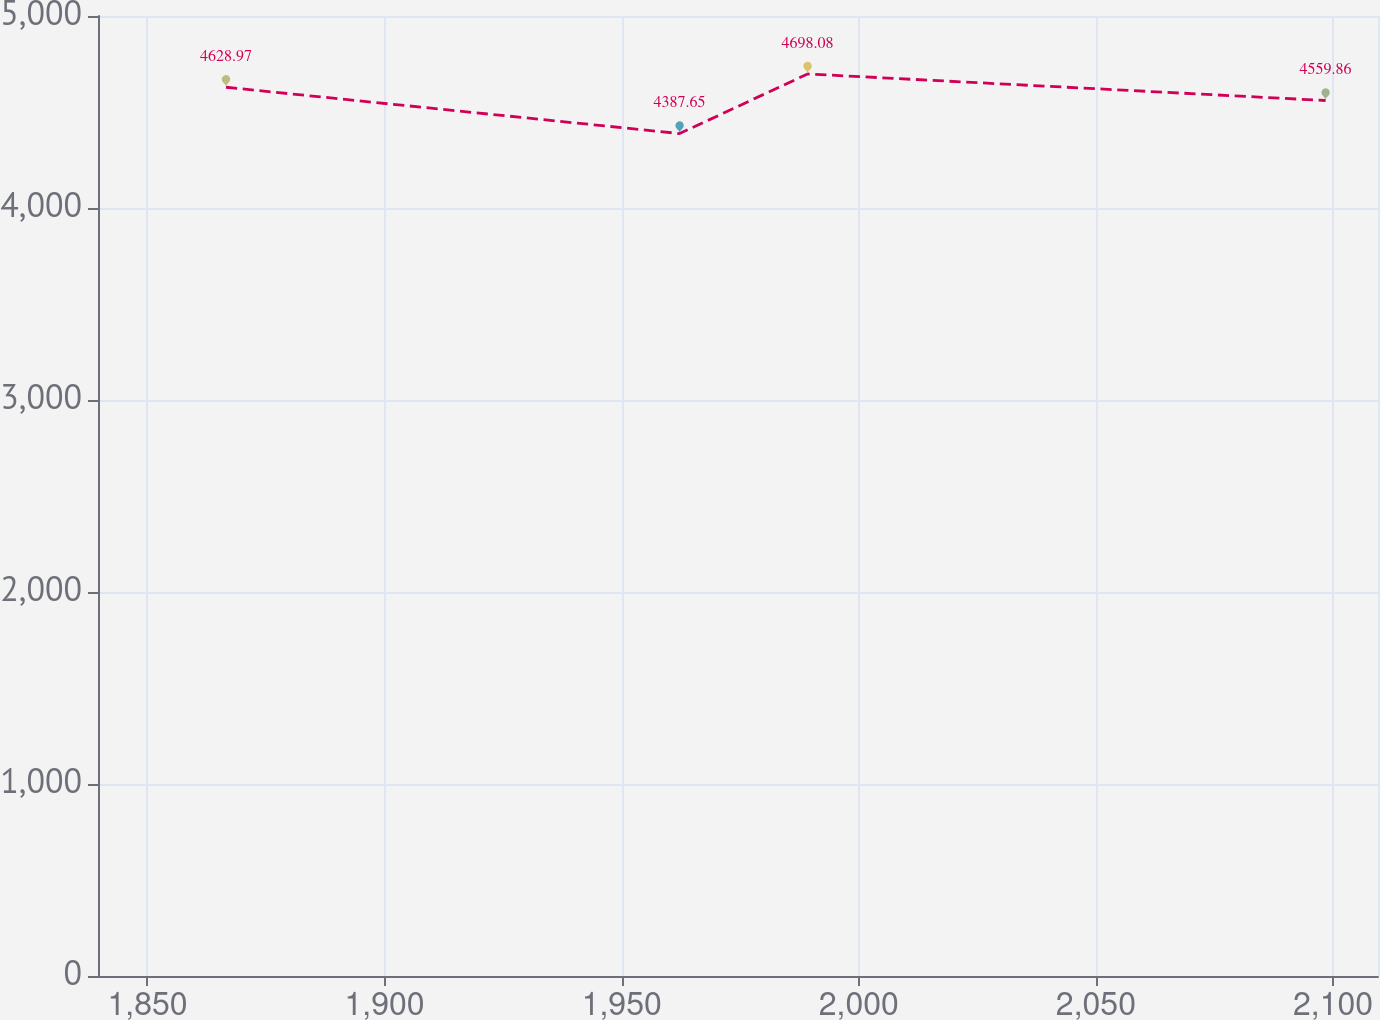Convert chart. <chart><loc_0><loc_0><loc_500><loc_500><line_chart><ecel><fcel>Unnamed: 1<nl><fcel>1866.56<fcel>4628.97<nl><fcel>1962.21<fcel>4387.65<nl><fcel>1989.2<fcel>4698.08<nl><fcel>2098.44<fcel>4559.86<nl><fcel>2136.48<fcel>5078.74<nl></chart> 